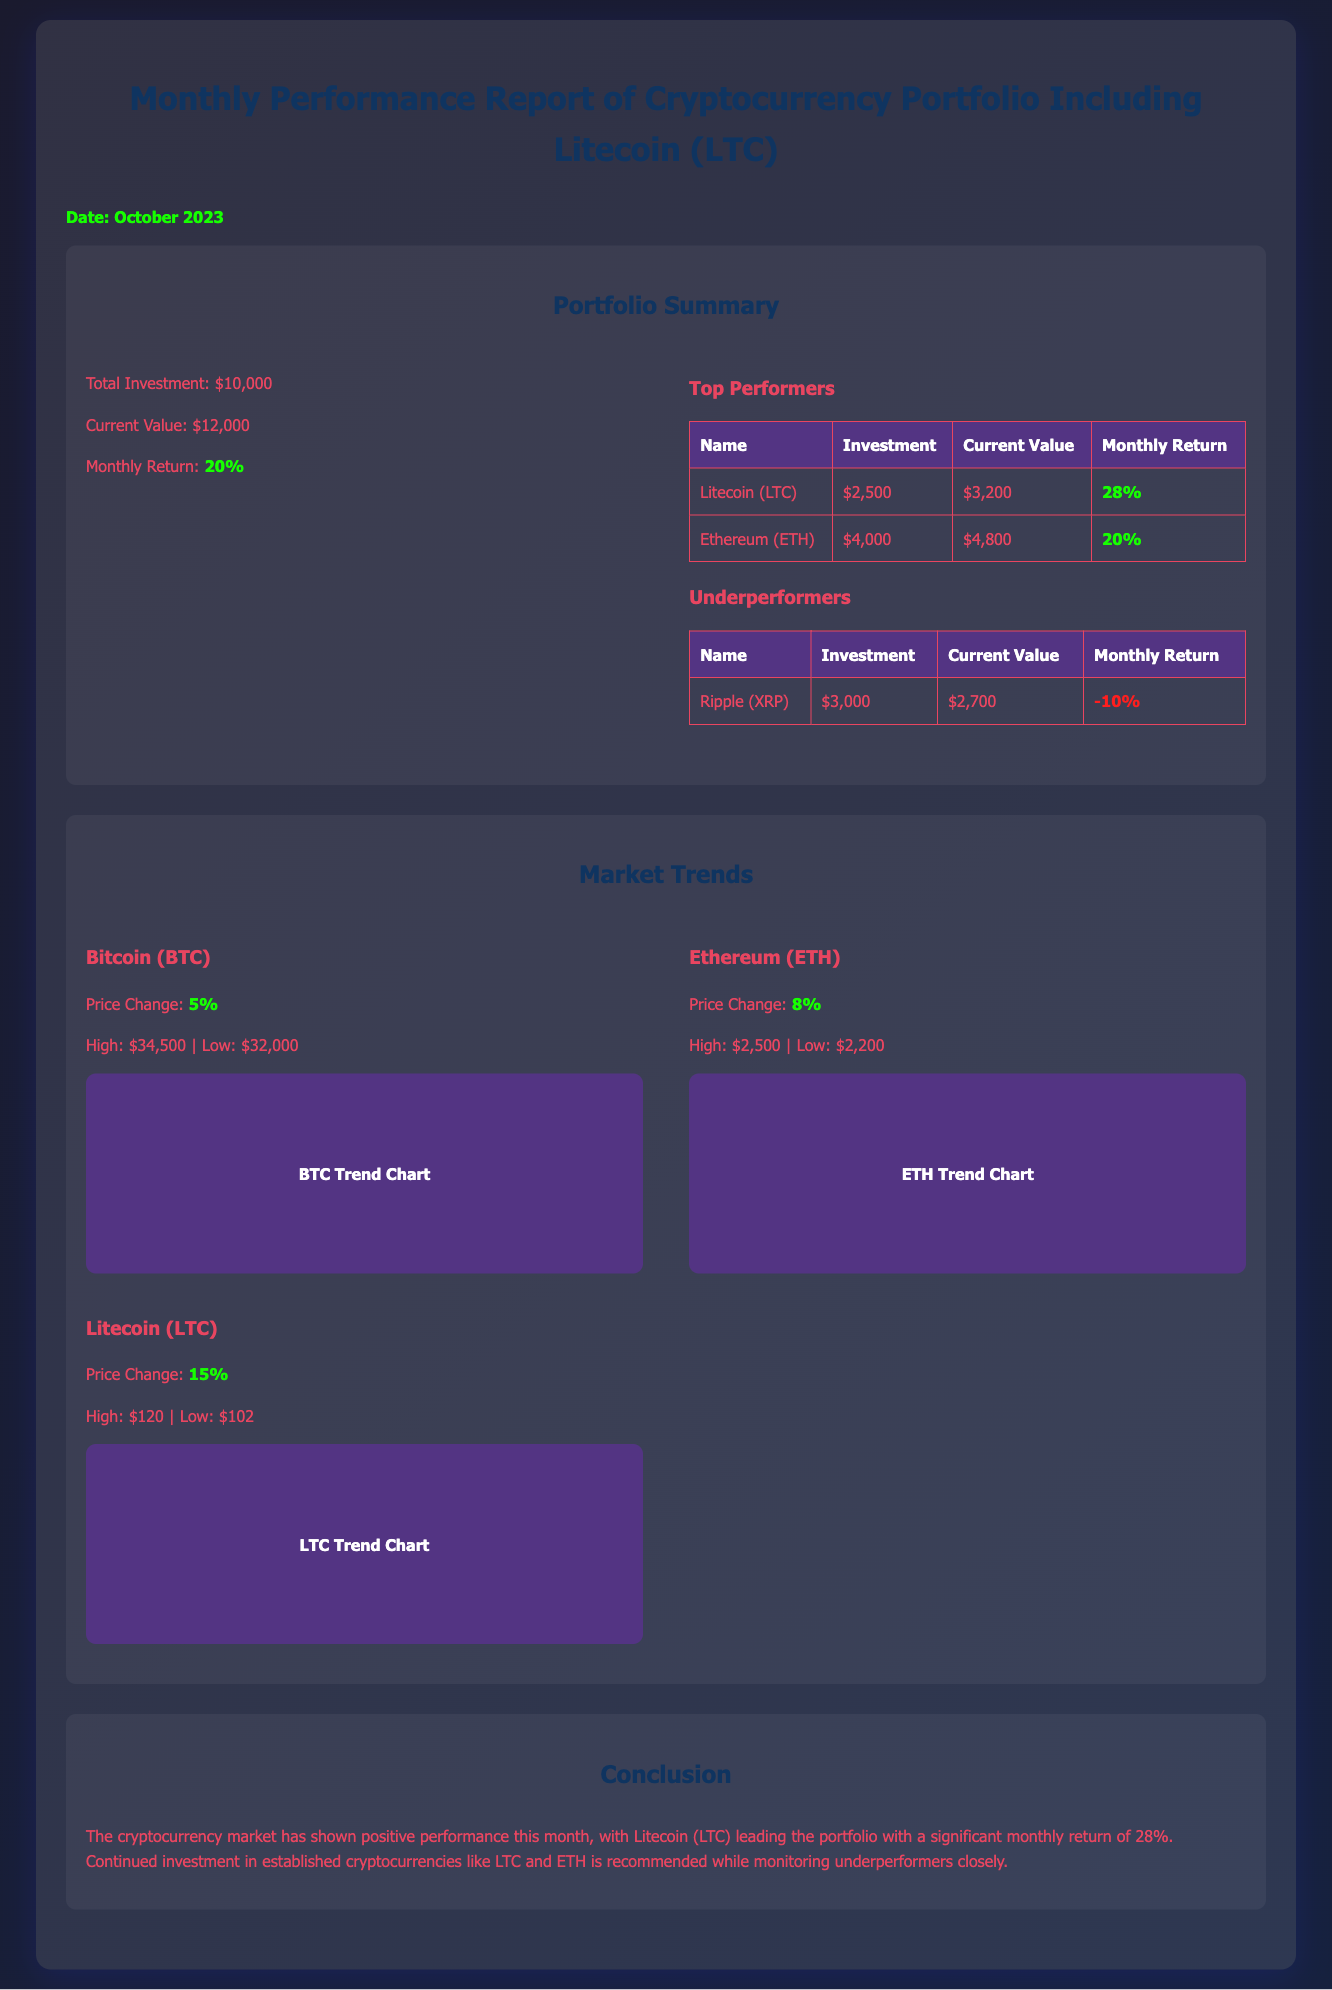What is the total investment? The total investment amount listed in the document is $10,000.
Answer: $10,000 What is the current value of the portfolio? The current value of the portfolio is specified as $12,000 in the document.
Answer: $12,000 What was the monthly return percentage? The monthly return percentage noted in the document is 20%.
Answer: 20% Which cryptocurrency had the highest monthly return? Litecoin (LTC) is mentioned as the top performer with a monthly return of 28%.
Answer: Litecoin (LTC) What is the investment amount in Ethereum (ETH)? The investment amount in Ethereum (ETH) is $4,000 according to the document.
Answer: $4,000 What was the price change for Litecoin (LTC)? The document states that the price change for Litecoin (LTC) was 15%.
Answer: 15% What is recommended based on the conclusion? The conclusion recommends continued investment in established cryptocurrencies like LTC and ETH.
Answer: Continued investment in LTC and ETH Which cryptocurrency is listed as an underperformer? Ripple (XRP) is highlighted as the underperformer in the document.
Answer: Ripple (XRP) 